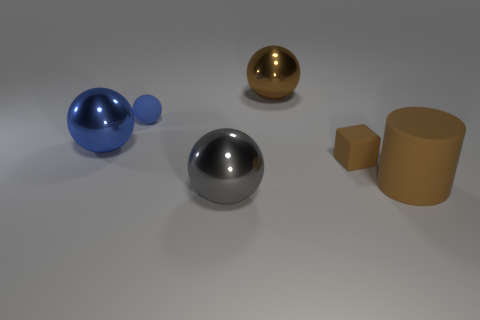Can you describe the properties of the materials shown in the image? Certainly! The image showcases objects with a variety of materials. The large and small blue spheres have a glossy and reflective surface, suggesting a smooth, possibly plastic or glass-like material. The metallic sphere has a highly reflective and smooth surface, indicative of metal. The golden object shares similar reflective properties but with a different hue, hinting at a different type of metal or a metal-like paint. The cylinder appears to have a less shiny, matte finish, which could be suggestive of metal with a coating or perhaps a dense plastic. Lastly, the small brown cube has a distinctly non-reflective, matte surface that gives the impression of a porous or fibrous material such as cardboard or wood. 